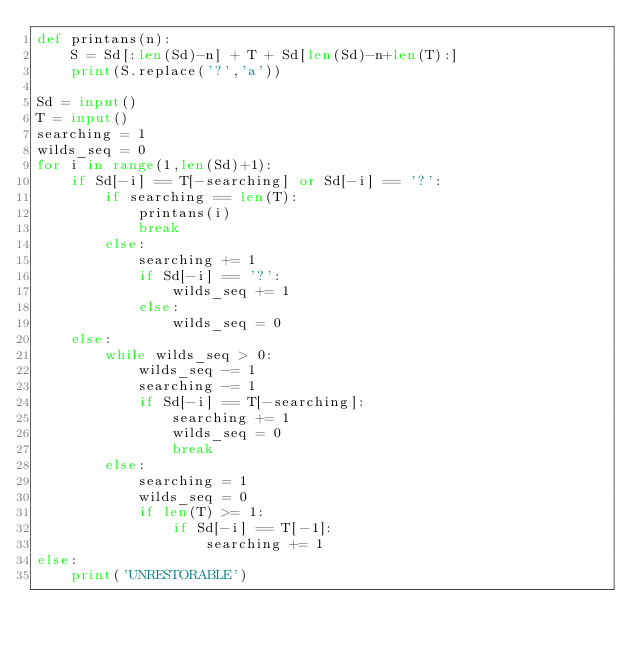Convert code to text. <code><loc_0><loc_0><loc_500><loc_500><_Python_>def printans(n):
    S = Sd[:len(Sd)-n] + T + Sd[len(Sd)-n+len(T):]
    print(S.replace('?','a'))

Sd = input()
T = input()
searching = 1
wilds_seq = 0
for i in range(1,len(Sd)+1):
    if Sd[-i] == T[-searching] or Sd[-i] == '?':
        if searching == len(T):
            printans(i)
            break
        else:
            searching += 1
            if Sd[-i] == '?':
                wilds_seq += 1
            else:
                wilds_seq = 0
    else:
        while wilds_seq > 0:
            wilds_seq -= 1
            searching -= 1
            if Sd[-i] == T[-searching]:
                searching += 1
                wilds_seq = 0
                break
        else:
            searching = 1
            wilds_seq = 0
            if len(T) >= 1:
                if Sd[-i] == T[-1]:
                    searching += 1
else:
    print('UNRESTORABLE')</code> 